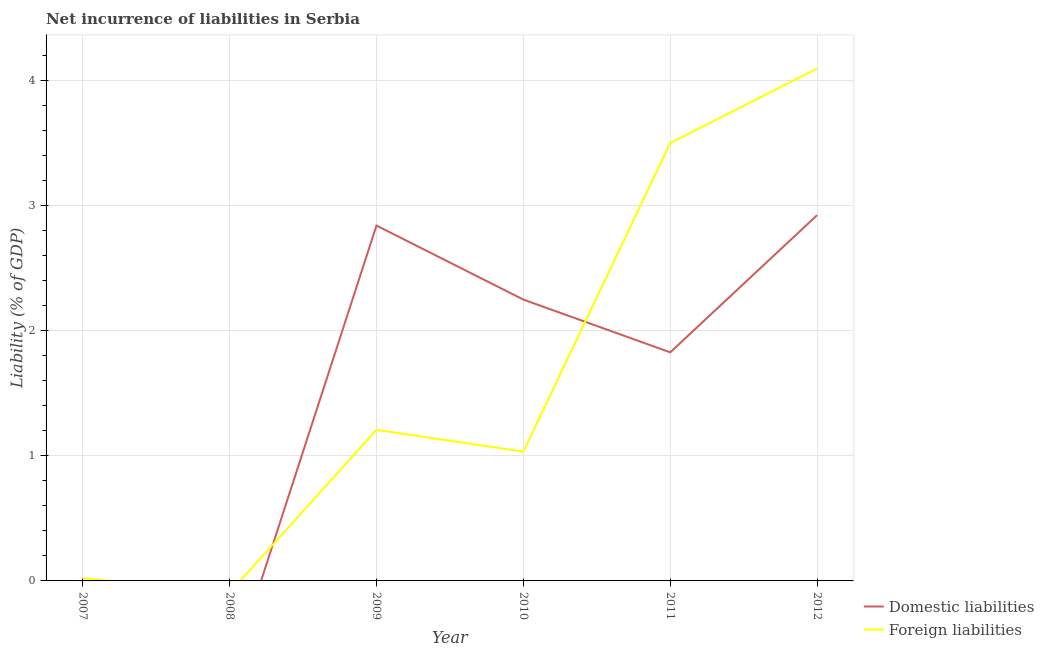How many different coloured lines are there?
Your answer should be compact. 2. What is the incurrence of domestic liabilities in 2011?
Provide a short and direct response. 1.83. Across all years, what is the maximum incurrence of domestic liabilities?
Make the answer very short. 2.93. In which year was the incurrence of foreign liabilities maximum?
Keep it short and to the point. 2012. What is the total incurrence of domestic liabilities in the graph?
Ensure brevity in your answer.  9.85. What is the difference between the incurrence of foreign liabilities in 2007 and that in 2009?
Give a very brief answer. -1.19. What is the difference between the incurrence of foreign liabilities in 2009 and the incurrence of domestic liabilities in 2010?
Offer a terse response. -1.04. What is the average incurrence of foreign liabilities per year?
Provide a succinct answer. 1.64. In the year 2012, what is the difference between the incurrence of domestic liabilities and incurrence of foreign liabilities?
Your response must be concise. -1.17. In how many years, is the incurrence of domestic liabilities greater than 0.8 %?
Provide a short and direct response. 4. What is the difference between the highest and the second highest incurrence of foreign liabilities?
Offer a terse response. 0.6. What is the difference between the highest and the lowest incurrence of domestic liabilities?
Ensure brevity in your answer.  2.93. In how many years, is the incurrence of foreign liabilities greater than the average incurrence of foreign liabilities taken over all years?
Ensure brevity in your answer.  2. Is the sum of the incurrence of foreign liabilities in 2007 and 2009 greater than the maximum incurrence of domestic liabilities across all years?
Provide a short and direct response. No. Does the incurrence of domestic liabilities monotonically increase over the years?
Your answer should be compact. No. Is the incurrence of foreign liabilities strictly less than the incurrence of domestic liabilities over the years?
Your answer should be very brief. No. How many lines are there?
Keep it short and to the point. 2. What is the difference between two consecutive major ticks on the Y-axis?
Offer a terse response. 1. Are the values on the major ticks of Y-axis written in scientific E-notation?
Provide a succinct answer. No. What is the title of the graph?
Give a very brief answer. Net incurrence of liabilities in Serbia. What is the label or title of the X-axis?
Provide a succinct answer. Year. What is the label or title of the Y-axis?
Ensure brevity in your answer.  Liability (% of GDP). What is the Liability (% of GDP) of Domestic liabilities in 2007?
Give a very brief answer. 0. What is the Liability (% of GDP) of Foreign liabilities in 2007?
Your answer should be very brief. 0.02. What is the Liability (% of GDP) of Domestic liabilities in 2008?
Ensure brevity in your answer.  0. What is the Liability (% of GDP) of Domestic liabilities in 2009?
Provide a short and direct response. 2.84. What is the Liability (% of GDP) in Foreign liabilities in 2009?
Give a very brief answer. 1.21. What is the Liability (% of GDP) in Domestic liabilities in 2010?
Offer a terse response. 2.25. What is the Liability (% of GDP) in Foreign liabilities in 2010?
Keep it short and to the point. 1.03. What is the Liability (% of GDP) in Domestic liabilities in 2011?
Keep it short and to the point. 1.83. What is the Liability (% of GDP) in Foreign liabilities in 2011?
Offer a terse response. 3.5. What is the Liability (% of GDP) of Domestic liabilities in 2012?
Offer a terse response. 2.93. What is the Liability (% of GDP) in Foreign liabilities in 2012?
Ensure brevity in your answer.  4.1. Across all years, what is the maximum Liability (% of GDP) of Domestic liabilities?
Your response must be concise. 2.93. Across all years, what is the maximum Liability (% of GDP) in Foreign liabilities?
Your response must be concise. 4.1. Across all years, what is the minimum Liability (% of GDP) of Domestic liabilities?
Keep it short and to the point. 0. Across all years, what is the minimum Liability (% of GDP) of Foreign liabilities?
Give a very brief answer. 0. What is the total Liability (% of GDP) of Domestic liabilities in the graph?
Make the answer very short. 9.85. What is the total Liability (% of GDP) in Foreign liabilities in the graph?
Keep it short and to the point. 9.87. What is the difference between the Liability (% of GDP) of Foreign liabilities in 2007 and that in 2009?
Keep it short and to the point. -1.19. What is the difference between the Liability (% of GDP) of Foreign liabilities in 2007 and that in 2010?
Offer a very short reply. -1.01. What is the difference between the Liability (% of GDP) of Foreign liabilities in 2007 and that in 2011?
Offer a terse response. -3.48. What is the difference between the Liability (% of GDP) in Foreign liabilities in 2007 and that in 2012?
Your answer should be very brief. -4.08. What is the difference between the Liability (% of GDP) of Domestic liabilities in 2009 and that in 2010?
Offer a very short reply. 0.59. What is the difference between the Liability (% of GDP) in Foreign liabilities in 2009 and that in 2010?
Your response must be concise. 0.17. What is the difference between the Liability (% of GDP) in Domestic liabilities in 2009 and that in 2011?
Your response must be concise. 1.01. What is the difference between the Liability (% of GDP) of Foreign liabilities in 2009 and that in 2011?
Provide a short and direct response. -2.29. What is the difference between the Liability (% of GDP) of Domestic liabilities in 2009 and that in 2012?
Your answer should be very brief. -0.08. What is the difference between the Liability (% of GDP) in Foreign liabilities in 2009 and that in 2012?
Your response must be concise. -2.89. What is the difference between the Liability (% of GDP) of Domestic liabilities in 2010 and that in 2011?
Keep it short and to the point. 0.42. What is the difference between the Liability (% of GDP) of Foreign liabilities in 2010 and that in 2011?
Provide a short and direct response. -2.47. What is the difference between the Liability (% of GDP) of Domestic liabilities in 2010 and that in 2012?
Provide a short and direct response. -0.68. What is the difference between the Liability (% of GDP) of Foreign liabilities in 2010 and that in 2012?
Make the answer very short. -3.06. What is the difference between the Liability (% of GDP) in Domestic liabilities in 2011 and that in 2012?
Your response must be concise. -1.1. What is the difference between the Liability (% of GDP) in Foreign liabilities in 2011 and that in 2012?
Keep it short and to the point. -0.6. What is the difference between the Liability (% of GDP) in Domestic liabilities in 2009 and the Liability (% of GDP) in Foreign liabilities in 2010?
Offer a very short reply. 1.81. What is the difference between the Liability (% of GDP) of Domestic liabilities in 2009 and the Liability (% of GDP) of Foreign liabilities in 2011?
Provide a succinct answer. -0.66. What is the difference between the Liability (% of GDP) in Domestic liabilities in 2009 and the Liability (% of GDP) in Foreign liabilities in 2012?
Provide a succinct answer. -1.26. What is the difference between the Liability (% of GDP) in Domestic liabilities in 2010 and the Liability (% of GDP) in Foreign liabilities in 2011?
Your response must be concise. -1.25. What is the difference between the Liability (% of GDP) of Domestic liabilities in 2010 and the Liability (% of GDP) of Foreign liabilities in 2012?
Make the answer very short. -1.85. What is the difference between the Liability (% of GDP) in Domestic liabilities in 2011 and the Liability (% of GDP) in Foreign liabilities in 2012?
Give a very brief answer. -2.27. What is the average Liability (% of GDP) in Domestic liabilities per year?
Give a very brief answer. 1.64. What is the average Liability (% of GDP) of Foreign liabilities per year?
Your answer should be very brief. 1.64. In the year 2009, what is the difference between the Liability (% of GDP) in Domestic liabilities and Liability (% of GDP) in Foreign liabilities?
Your answer should be compact. 1.63. In the year 2010, what is the difference between the Liability (% of GDP) of Domestic liabilities and Liability (% of GDP) of Foreign liabilities?
Offer a terse response. 1.22. In the year 2011, what is the difference between the Liability (% of GDP) of Domestic liabilities and Liability (% of GDP) of Foreign liabilities?
Your response must be concise. -1.67. In the year 2012, what is the difference between the Liability (% of GDP) in Domestic liabilities and Liability (% of GDP) in Foreign liabilities?
Provide a short and direct response. -1.17. What is the ratio of the Liability (% of GDP) in Foreign liabilities in 2007 to that in 2009?
Provide a short and direct response. 0.02. What is the ratio of the Liability (% of GDP) in Foreign liabilities in 2007 to that in 2010?
Offer a terse response. 0.02. What is the ratio of the Liability (% of GDP) of Foreign liabilities in 2007 to that in 2011?
Your answer should be compact. 0.01. What is the ratio of the Liability (% of GDP) in Foreign liabilities in 2007 to that in 2012?
Your answer should be very brief. 0.01. What is the ratio of the Liability (% of GDP) in Domestic liabilities in 2009 to that in 2010?
Offer a terse response. 1.26. What is the ratio of the Liability (% of GDP) in Foreign liabilities in 2009 to that in 2010?
Provide a succinct answer. 1.17. What is the ratio of the Liability (% of GDP) of Domestic liabilities in 2009 to that in 2011?
Make the answer very short. 1.55. What is the ratio of the Liability (% of GDP) in Foreign liabilities in 2009 to that in 2011?
Your response must be concise. 0.35. What is the ratio of the Liability (% of GDP) in Domestic liabilities in 2009 to that in 2012?
Offer a terse response. 0.97. What is the ratio of the Liability (% of GDP) of Foreign liabilities in 2009 to that in 2012?
Offer a very short reply. 0.29. What is the ratio of the Liability (% of GDP) in Domestic liabilities in 2010 to that in 2011?
Provide a succinct answer. 1.23. What is the ratio of the Liability (% of GDP) in Foreign liabilities in 2010 to that in 2011?
Keep it short and to the point. 0.3. What is the ratio of the Liability (% of GDP) in Domestic liabilities in 2010 to that in 2012?
Offer a terse response. 0.77. What is the ratio of the Liability (% of GDP) in Foreign liabilities in 2010 to that in 2012?
Offer a terse response. 0.25. What is the ratio of the Liability (% of GDP) in Domestic liabilities in 2011 to that in 2012?
Your response must be concise. 0.62. What is the ratio of the Liability (% of GDP) in Foreign liabilities in 2011 to that in 2012?
Provide a short and direct response. 0.85. What is the difference between the highest and the second highest Liability (% of GDP) in Domestic liabilities?
Keep it short and to the point. 0.08. What is the difference between the highest and the second highest Liability (% of GDP) of Foreign liabilities?
Provide a succinct answer. 0.6. What is the difference between the highest and the lowest Liability (% of GDP) in Domestic liabilities?
Your answer should be very brief. 2.93. What is the difference between the highest and the lowest Liability (% of GDP) of Foreign liabilities?
Provide a succinct answer. 4.1. 